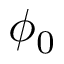Convert formula to latex. <formula><loc_0><loc_0><loc_500><loc_500>\phi _ { 0 }</formula> 